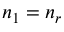Convert formula to latex. <formula><loc_0><loc_0><loc_500><loc_500>n _ { 1 } = n _ { r }</formula> 